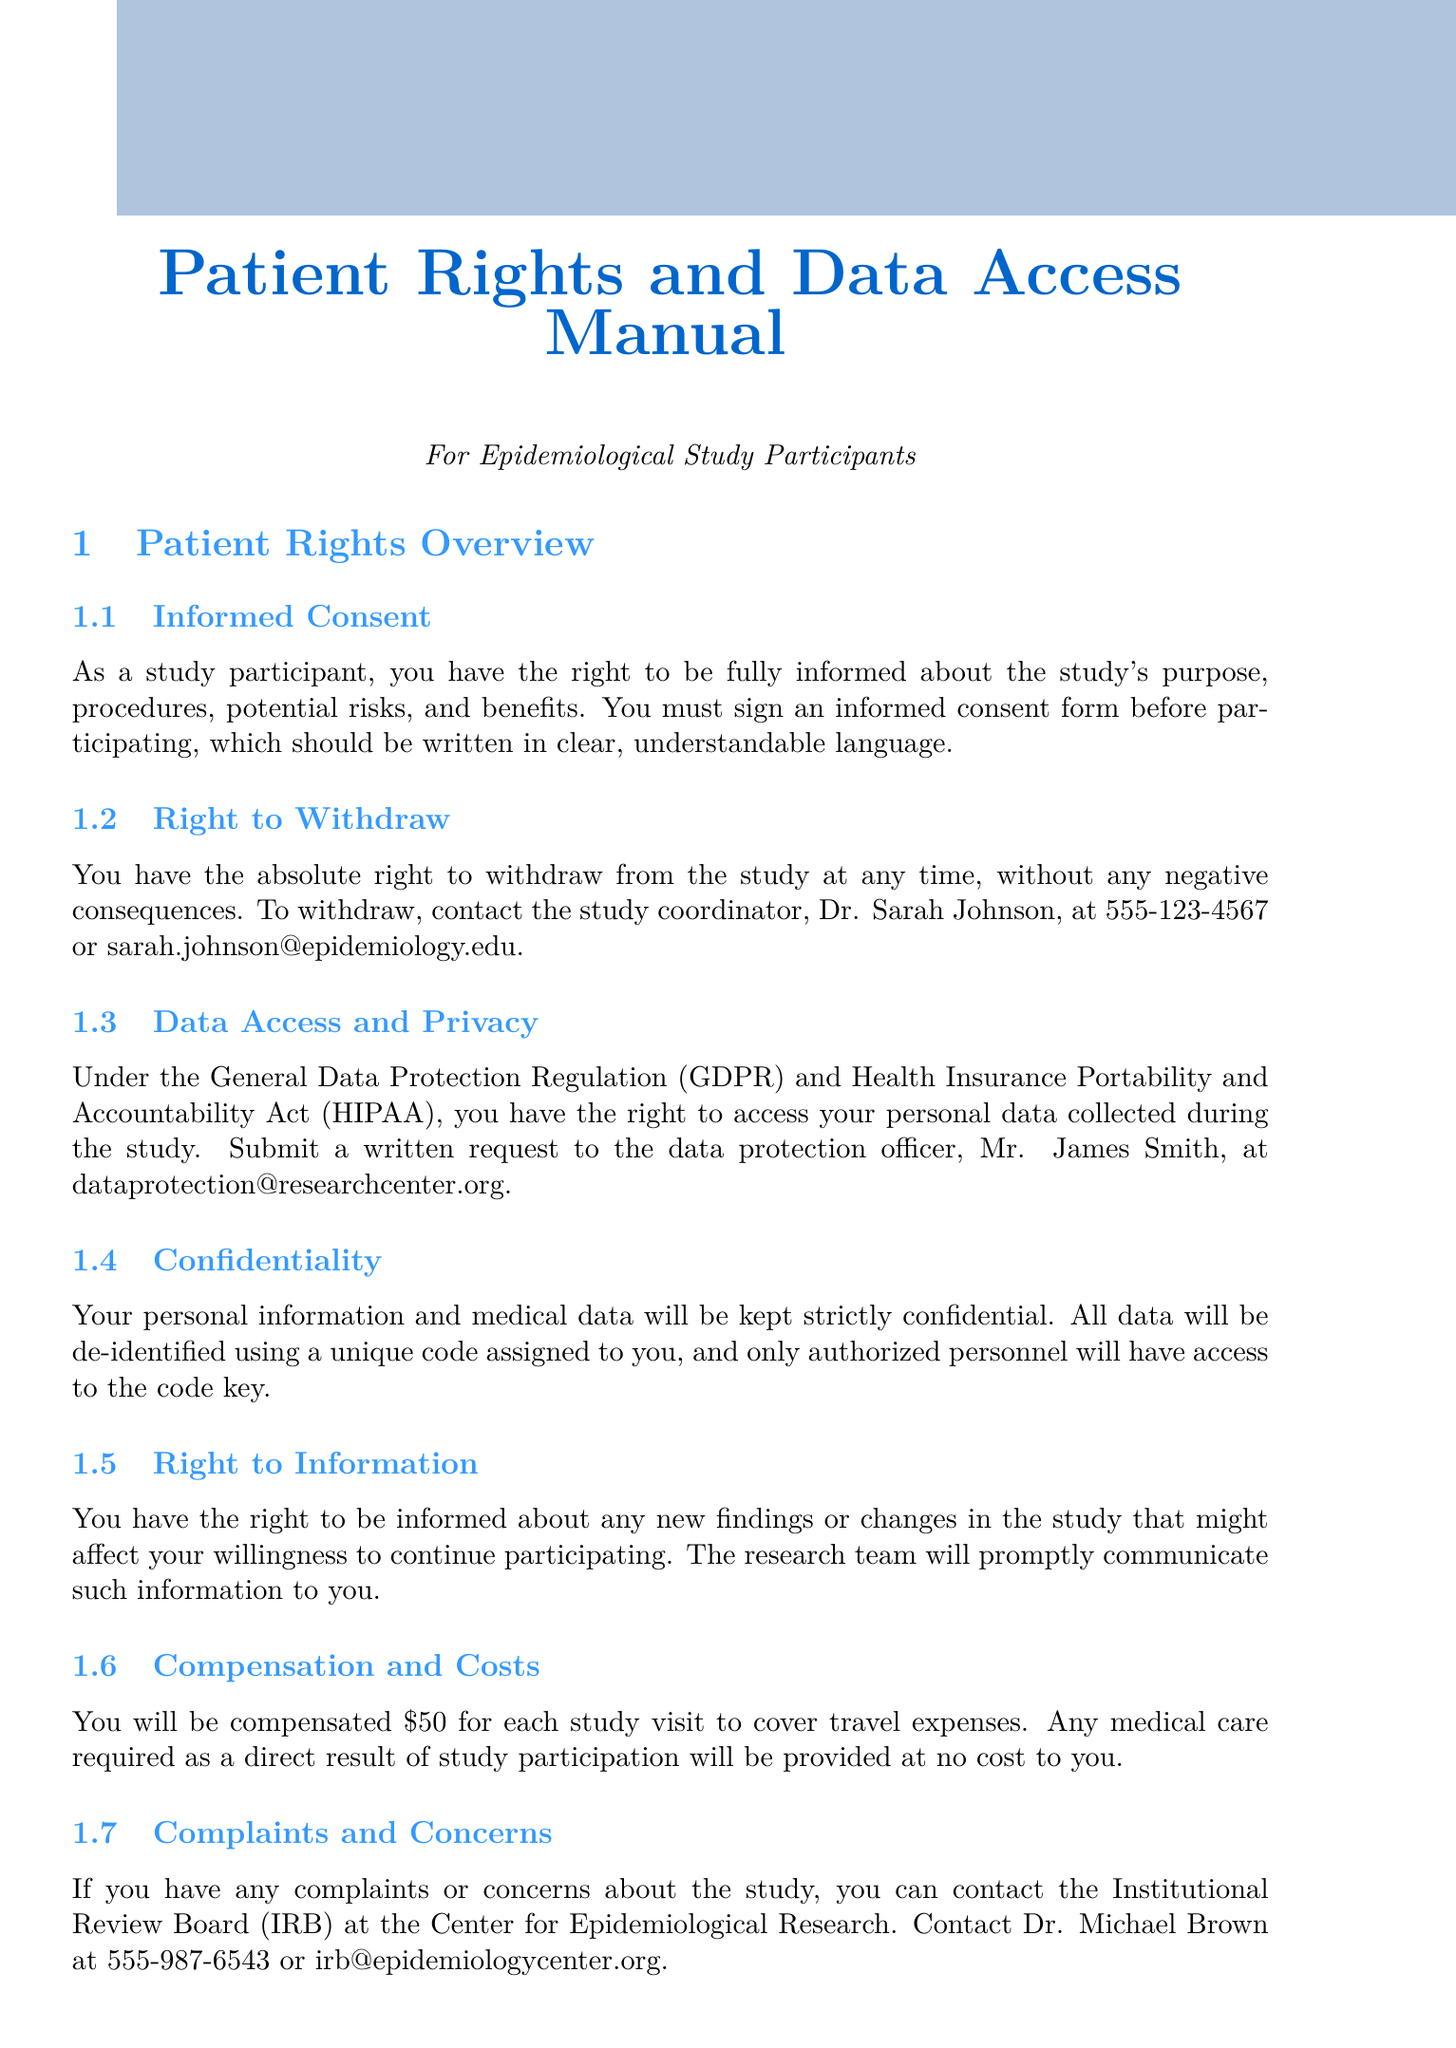What is the name of the study coordinator? The document states that the study coordinator is Dr. Sarah Johnson.
Answer: Dr. Sarah Johnson What is the compensation for each study visit? The manual mentions that you will be compensated $50 for each study visit.
Answer: $50 How many years will data be securely stored after study completion? The manual specifies that data will be stored for 10 years after study completion.
Answer: 10 years Who can you contact for complaints or concerns about the study? According to the document, complaints can be directed to Dr. Michael Brown at the Institutional Review Board.
Answer: Dr. Michael Brown What should you provide to verify your identity for data access? The document states you should provide a copy of a government-issued ID or passport.
Answer: Government-issued ID What is the expected completion date for study results? The manual indicates that the summary of findings will be available upon study completion, expected in December 2024.
Answer: December 2024 What do you need to do first to withdraw from the study? The document states you should contact the study coordinator to express your intention to withdraw.
Answer: Contact the study coordinator How long does it typically take to process a data access request? According to the document, processing a data request typically takes 30 days from receipt.
Answer: 30 days Can you refuse specific tests without withdrawing from the study? The manual affirms that you have the right to refuse specific tests without withdrawing from the entire study.
Answer: Yes 